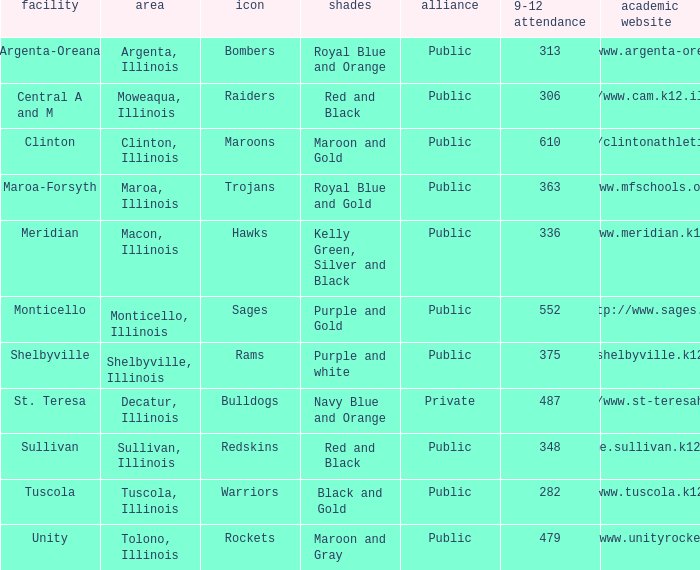How many different combinations of team colors are there in all the schools in Maroa, Illinois? 1.0. 